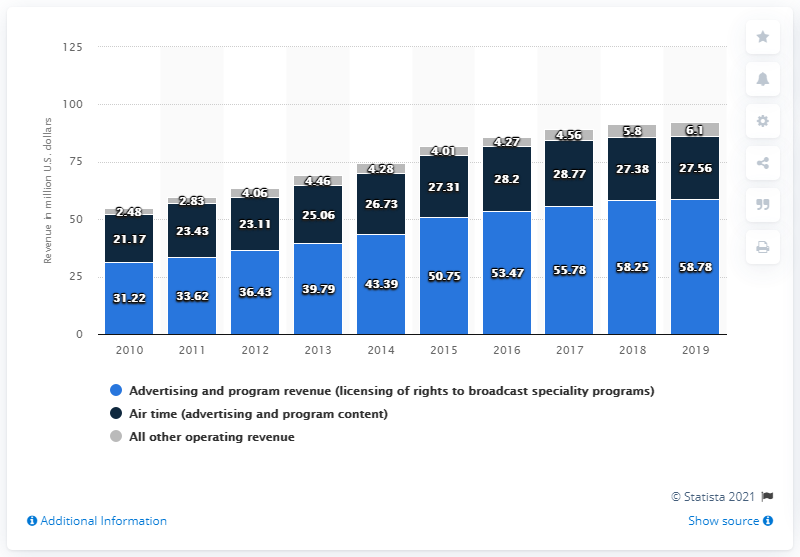What category contributes the most to revenue according to the image? According to the image, 'All other operating revenue' contributes the most to the overall revenue across the years displayed. 